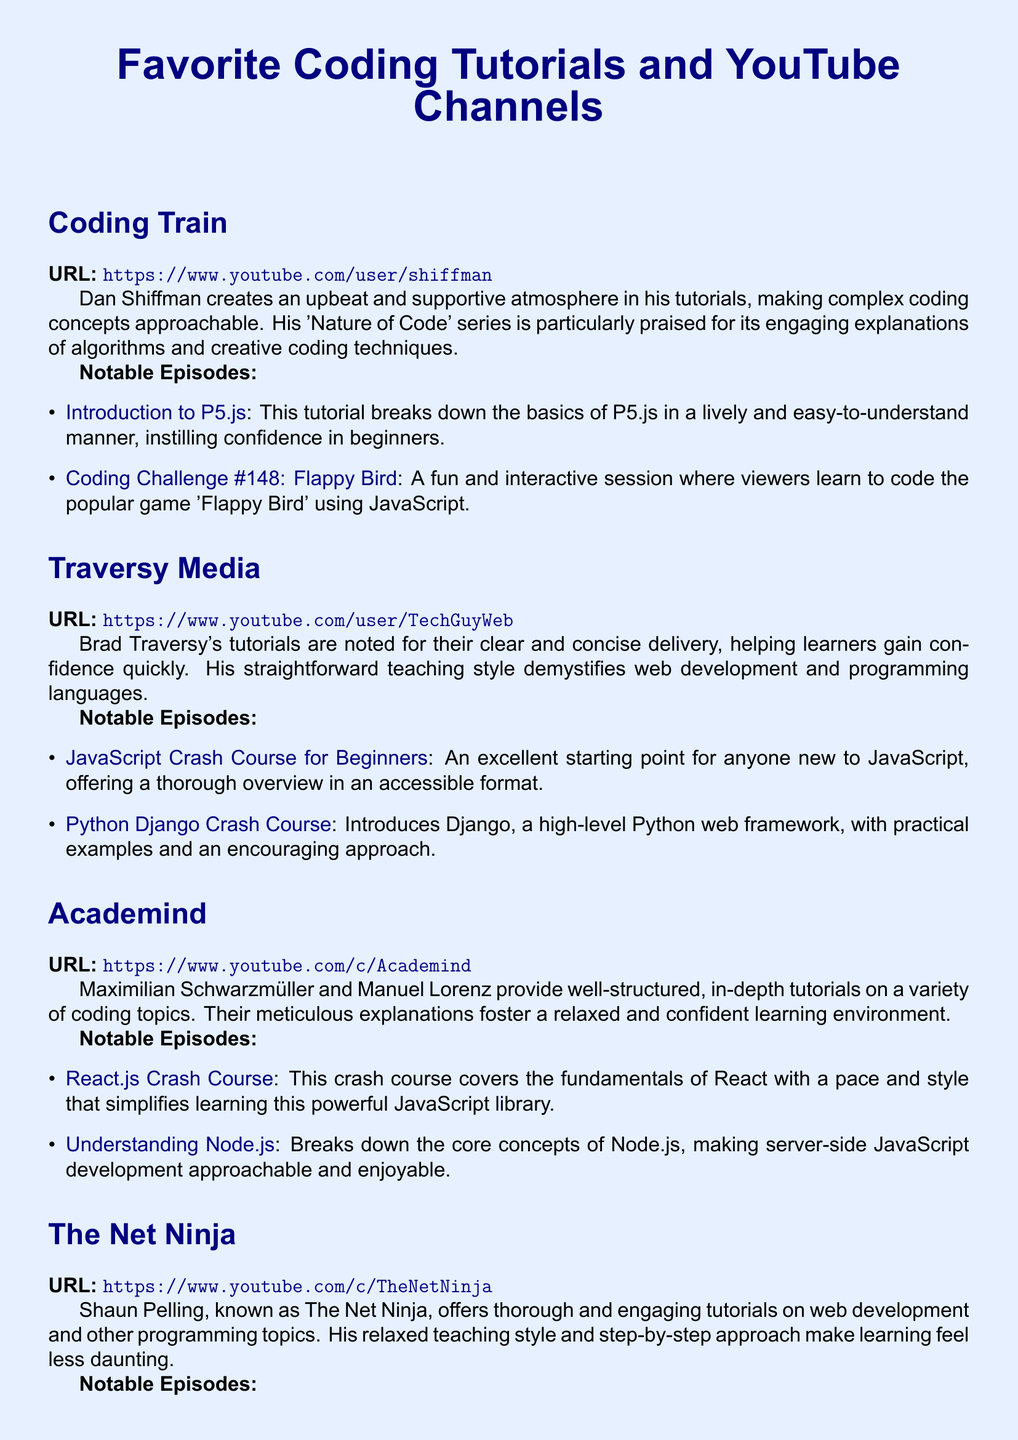What is the URL for Coding Train? The URL is listed in the section for Coding Train as the official website at the beginning of the document.
Answer: https://www.youtube.com/user/shiffman Who creates an upbeat atmosphere in tutorials? The document describes Dan Shiffman as the creator of lively tutorials that foster a supportive learning environment.
Answer: Dan Shiffman What is the title of a notable episode from Traversy Media? The document lists specific episodes from Traversy Media, providing clear titles for each.
Answer: JavaScript Crash Course for Beginners Which YouTube channel is known for a calm teaching style? The text mentions Shaun Pelling of The Net Ninja as having a relaxed teaching approach.
Answer: The Net Ninja How many notable episodes are listed for Academind? The document enumerates specific episodes under Academind, providing a count of notable episodes within that section.
Answer: 2 